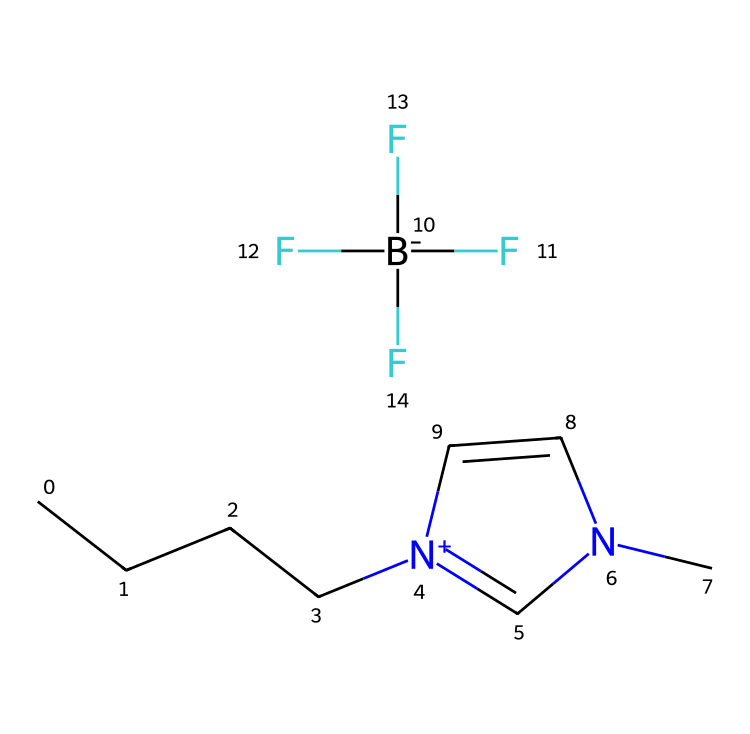What is the name of this ionic liquid? The SMILES representation of the compound shows a butyl group (CCCC), a methyl imidazolium ring ([n+]1cn(C)cc1), and a tetrafluoroborate anion ([B-](F)(F)(F)F). Together, these components define the compound as 1-butyl-3-methylimidazolium tetrafluoroborate.
Answer: 1-butyl-3-methylimidazolium tetrafluoroborate How many fluorine atoms are present in this compound? The tetrafluoroborate anion is indicated by the [B-](F)(F)(F)F part of the SMILES, which shows four fluorine atoms bonded to the boron atom. Hence, there are four fluorine atoms in total.
Answer: four What is the total number of nitrogen atoms in this ionic liquid? The imidazolium ring contains one nitrogen atom in the ring structure and another nitrogen atom in the butyl group, making it a total of two nitrogen atoms present in the compound.
Answer: two Which part of this ionic liquid contributes to its cationic nature? The presence of the imidazolium ring ([n+]1cn(C)cc1), which carries a positive charge on one of the nitrogen atoms, contributes to the cationic character of the ionic liquid. This positively charged structure is essential for its function.
Answer: imidazolium ring Is this ionic liquid considered hydrophilic or hydrophobic? The significant presence of the butyl group (CCCC), which is nonpolar, suggests that this ionic liquid is hydrophobic in nature. While the imidazolium ring may show some polar characteristics, the overall structure leans toward hydrophobicity.
Answer: hydrophobic 